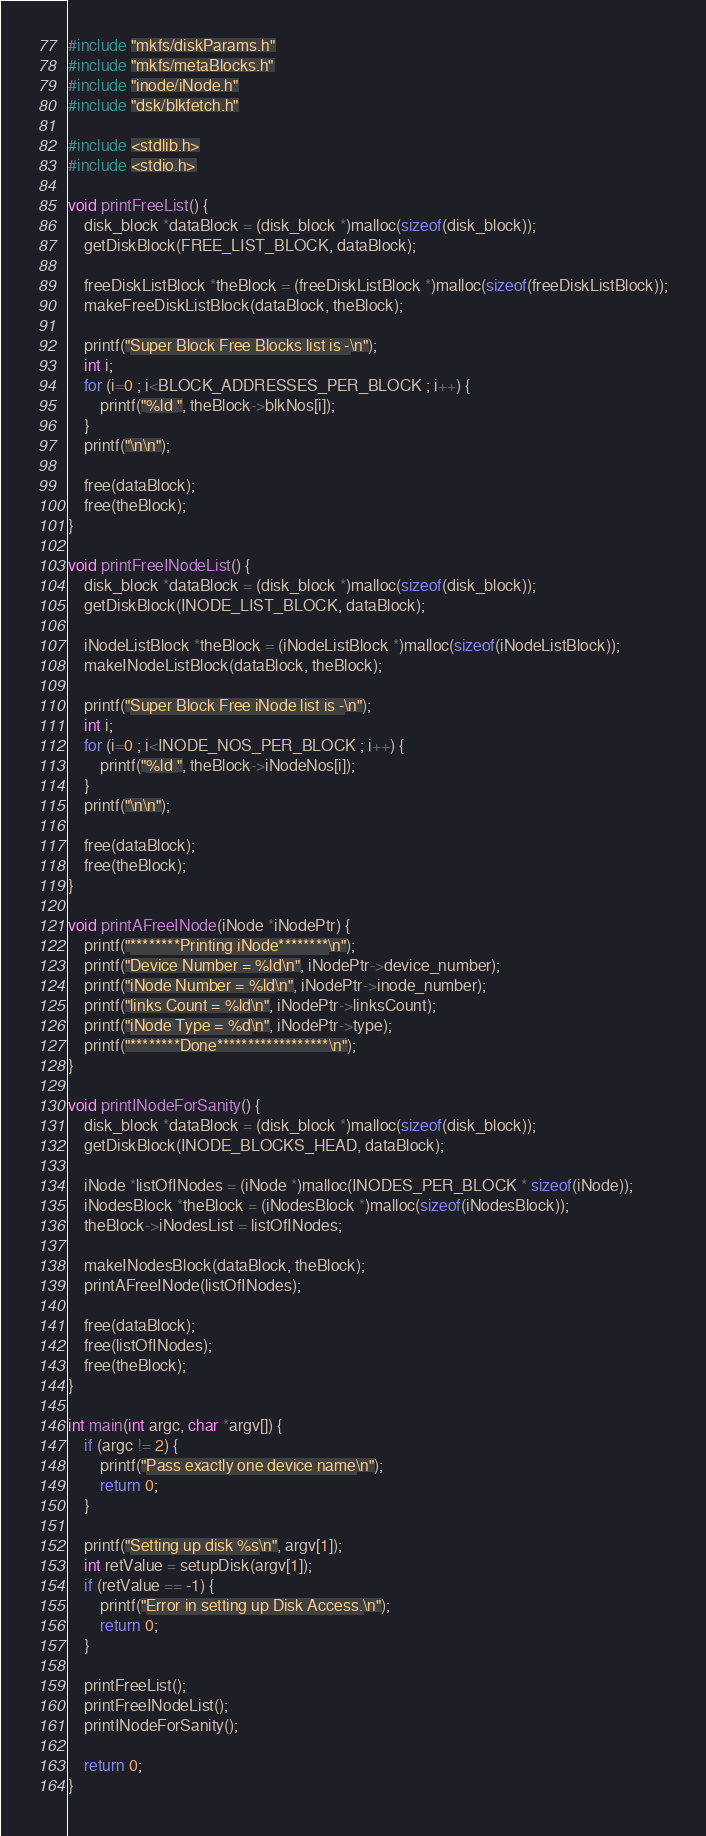<code> <loc_0><loc_0><loc_500><loc_500><_C_>#include "mkfs/diskParams.h"
#include "mkfs/metaBlocks.h"
#include "inode/iNode.h"
#include "dsk/blkfetch.h"

#include <stdlib.h>
#include <stdio.h>

void printFreeList() {
	disk_block *dataBlock = (disk_block *)malloc(sizeof(disk_block));
	getDiskBlock(FREE_LIST_BLOCK, dataBlock);

	freeDiskListBlock *theBlock = (freeDiskListBlock *)malloc(sizeof(freeDiskListBlock));
	makeFreeDiskListBlock(dataBlock, theBlock);

	printf("Super Block Free Blocks list is -\n");
	int i;
	for (i=0 ; i<BLOCK_ADDRESSES_PER_BLOCK ; i++) {
		printf("%ld ", theBlock->blkNos[i]);
	}
	printf("\n\n");

	free(dataBlock);
	free(theBlock);
}

void printFreeINodeList() {
	disk_block *dataBlock = (disk_block *)malloc(sizeof(disk_block));
	getDiskBlock(INODE_LIST_BLOCK, dataBlock);

	iNodeListBlock *theBlock = (iNodeListBlock *)malloc(sizeof(iNodeListBlock));
	makeINodeListBlock(dataBlock, theBlock);

	printf("Super Block Free iNode list is -\n");
	int i;
	for (i=0 ; i<INODE_NOS_PER_BLOCK ; i++) {
		printf("%ld ", theBlock->iNodeNos[i]);
	}
	printf("\n\n");

	free(dataBlock);
	free(theBlock);
}

void printAFreeINode(iNode *iNodePtr) {
	printf("********Printing iNode********\n");
	printf("Device Number = %ld\n", iNodePtr->device_number);
	printf("iNode Number = %ld\n", iNodePtr->inode_number);
	printf("links Count = %ld\n", iNodePtr->linksCount);
	printf("iNode Type = %d\n", iNodePtr->type);
	printf("********Done******************\n");
}

void printINodeForSanity() {
	disk_block *dataBlock = (disk_block *)malloc(sizeof(disk_block));
	getDiskBlock(INODE_BLOCKS_HEAD, dataBlock);

	iNode *listOfINodes = (iNode *)malloc(INODES_PER_BLOCK * sizeof(iNode));
	iNodesBlock *theBlock = (iNodesBlock *)malloc(sizeof(iNodesBlock));
	theBlock->iNodesList = listOfINodes;

	makeINodesBlock(dataBlock, theBlock);
	printAFreeINode(listOfINodes);

	free(dataBlock);
	free(listOfINodes);
	free(theBlock);
}

int main(int argc, char *argv[]) {
	if (argc != 2) {
		printf("Pass exactly one device name\n");
		return 0;
	}

	printf("Setting up disk %s\n", argv[1]);
	int retValue = setupDisk(argv[1]);
	if (retValue == -1) {
		printf("Error in setting up Disk Access.\n");
		return 0;
	}

	printFreeList();
	printFreeINodeList();
	printINodeForSanity();

	return 0;
}

</code> 